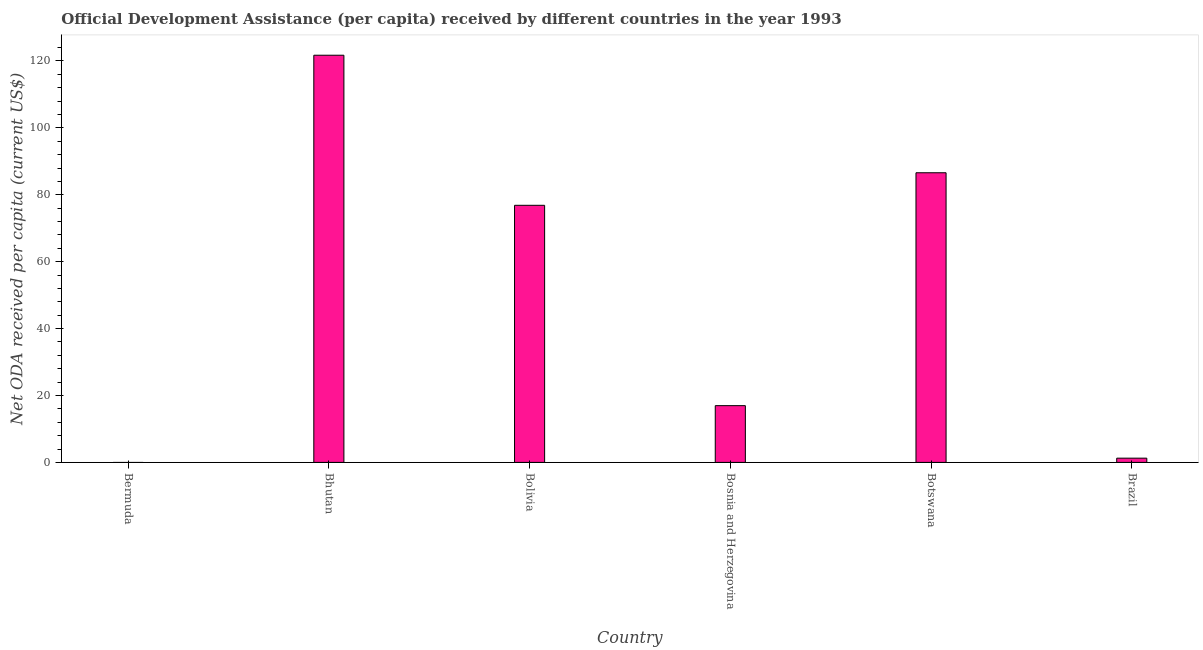Does the graph contain any zero values?
Offer a terse response. Yes. Does the graph contain grids?
Make the answer very short. No. What is the title of the graph?
Your answer should be compact. Official Development Assistance (per capita) received by different countries in the year 1993. What is the label or title of the X-axis?
Ensure brevity in your answer.  Country. What is the label or title of the Y-axis?
Your response must be concise. Net ODA received per capita (current US$). What is the net oda received per capita in Bhutan?
Provide a short and direct response. 121.71. Across all countries, what is the maximum net oda received per capita?
Your answer should be compact. 121.71. In which country was the net oda received per capita maximum?
Provide a short and direct response. Bhutan. What is the sum of the net oda received per capita?
Keep it short and to the point. 303.37. What is the difference between the net oda received per capita in Bhutan and Botswana?
Your response must be concise. 35.13. What is the average net oda received per capita per country?
Provide a succinct answer. 50.56. What is the median net oda received per capita?
Make the answer very short. 46.91. In how many countries, is the net oda received per capita greater than 68 US$?
Your answer should be compact. 3. What is the ratio of the net oda received per capita in Bolivia to that in Brazil?
Your answer should be very brief. 60.69. Is the difference between the net oda received per capita in Bolivia and Bosnia and Herzegovina greater than the difference between any two countries?
Make the answer very short. No. What is the difference between the highest and the second highest net oda received per capita?
Provide a short and direct response. 35.13. Is the sum of the net oda received per capita in Bolivia and Brazil greater than the maximum net oda received per capita across all countries?
Offer a very short reply. No. What is the difference between the highest and the lowest net oda received per capita?
Give a very brief answer. 121.71. Are all the bars in the graph horizontal?
Make the answer very short. No. How many countries are there in the graph?
Make the answer very short. 6. What is the difference between two consecutive major ticks on the Y-axis?
Offer a terse response. 20. What is the Net ODA received per capita (current US$) in Bhutan?
Your answer should be compact. 121.71. What is the Net ODA received per capita (current US$) of Bolivia?
Keep it short and to the point. 76.85. What is the Net ODA received per capita (current US$) in Bosnia and Herzegovina?
Provide a short and direct response. 16.96. What is the Net ODA received per capita (current US$) of Botswana?
Your answer should be compact. 86.58. What is the Net ODA received per capita (current US$) in Brazil?
Offer a very short reply. 1.27. What is the difference between the Net ODA received per capita (current US$) in Bhutan and Bolivia?
Provide a succinct answer. 44.86. What is the difference between the Net ODA received per capita (current US$) in Bhutan and Bosnia and Herzegovina?
Offer a very short reply. 104.75. What is the difference between the Net ODA received per capita (current US$) in Bhutan and Botswana?
Make the answer very short. 35.13. What is the difference between the Net ODA received per capita (current US$) in Bhutan and Brazil?
Keep it short and to the point. 120.45. What is the difference between the Net ODA received per capita (current US$) in Bolivia and Bosnia and Herzegovina?
Provide a succinct answer. 59.89. What is the difference between the Net ODA received per capita (current US$) in Bolivia and Botswana?
Keep it short and to the point. -9.73. What is the difference between the Net ODA received per capita (current US$) in Bolivia and Brazil?
Keep it short and to the point. 75.58. What is the difference between the Net ODA received per capita (current US$) in Bosnia and Herzegovina and Botswana?
Your response must be concise. -69.62. What is the difference between the Net ODA received per capita (current US$) in Bosnia and Herzegovina and Brazil?
Ensure brevity in your answer.  15.7. What is the difference between the Net ODA received per capita (current US$) in Botswana and Brazil?
Give a very brief answer. 85.31. What is the ratio of the Net ODA received per capita (current US$) in Bhutan to that in Bolivia?
Offer a terse response. 1.58. What is the ratio of the Net ODA received per capita (current US$) in Bhutan to that in Bosnia and Herzegovina?
Ensure brevity in your answer.  7.18. What is the ratio of the Net ODA received per capita (current US$) in Bhutan to that in Botswana?
Offer a very short reply. 1.41. What is the ratio of the Net ODA received per capita (current US$) in Bhutan to that in Brazil?
Ensure brevity in your answer.  96.12. What is the ratio of the Net ODA received per capita (current US$) in Bolivia to that in Bosnia and Herzegovina?
Ensure brevity in your answer.  4.53. What is the ratio of the Net ODA received per capita (current US$) in Bolivia to that in Botswana?
Provide a short and direct response. 0.89. What is the ratio of the Net ODA received per capita (current US$) in Bolivia to that in Brazil?
Your answer should be very brief. 60.69. What is the ratio of the Net ODA received per capita (current US$) in Bosnia and Herzegovina to that in Botswana?
Make the answer very short. 0.2. What is the ratio of the Net ODA received per capita (current US$) in Bosnia and Herzegovina to that in Brazil?
Your answer should be compact. 13.39. What is the ratio of the Net ODA received per capita (current US$) in Botswana to that in Brazil?
Keep it short and to the point. 68.38. 